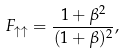Convert formula to latex. <formula><loc_0><loc_0><loc_500><loc_500>F _ { \uparrow \uparrow } = \frac { 1 + \beta ^ { 2 } } { ( 1 + \beta ) ^ { 2 } } ,</formula> 